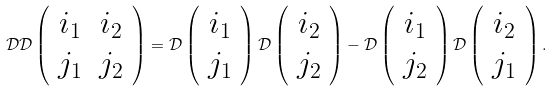Convert formula to latex. <formula><loc_0><loc_0><loc_500><loc_500>\mathcal { D } \mathcal { D } \left ( \begin{array} { c c } i _ { 1 } & i _ { 2 } \\ j _ { 1 } & j _ { 2 } \end{array} \right ) = \mathcal { D } \left ( \begin{array} { c } i _ { 1 } \\ j _ { 1 } \end{array} \right ) \mathcal { D } \left ( \begin{array} { c } i _ { 2 } \\ j _ { 2 } \end{array} \right ) - \mathcal { D } \left ( \begin{array} { c } i _ { 1 } \\ j _ { 2 } \end{array} \right ) \mathcal { D } \left ( \begin{array} { c } i _ { 2 } \\ j _ { 1 } \end{array} \right ) .</formula> 